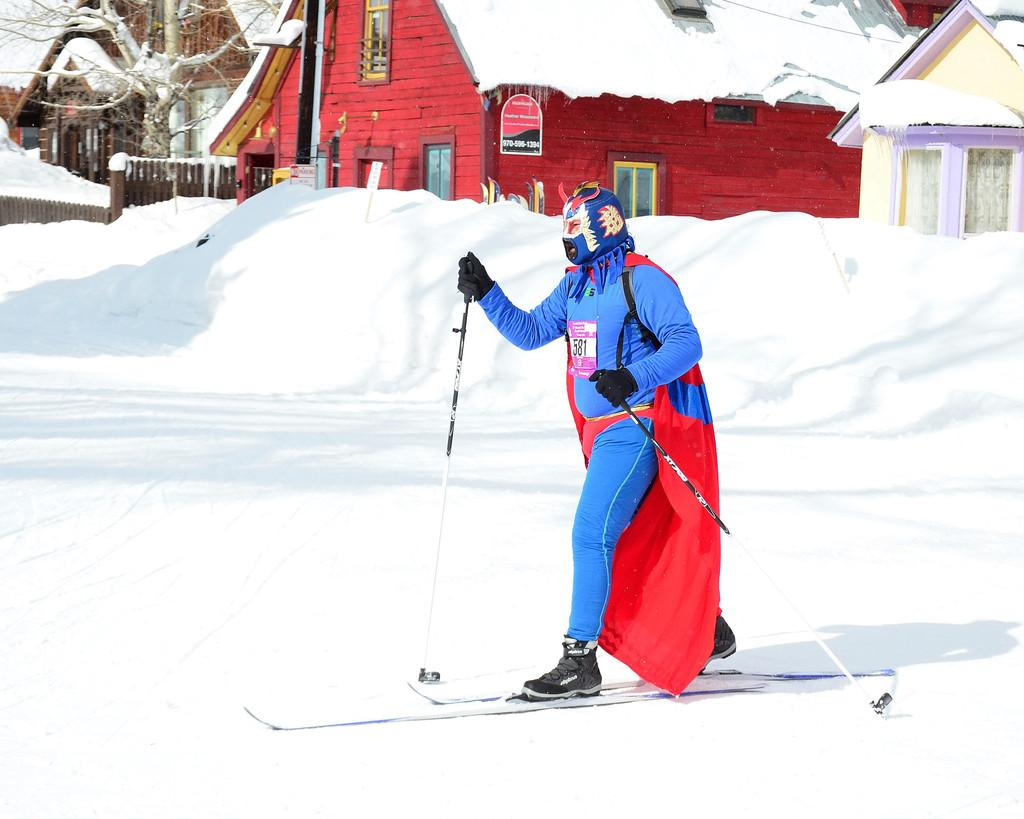What activity is the person in the image engaged in? The person is skiing on the snow. What equipment is the person using for skiing? The person is using ski boards and holding sticks, which are likely ski poles. What can be observed about the person's attire in the image? The person is wearing a costume. What type of natural environment is visible in the background of the image? There are houses, a tree, and a wooden fence in the background of the image. Can you see any caves in the background of the image? There are no caves visible in the background of the image. Is the person skiing in the rain in the image? The image does not show any rain, and the person is skiing on snow, not in water. 